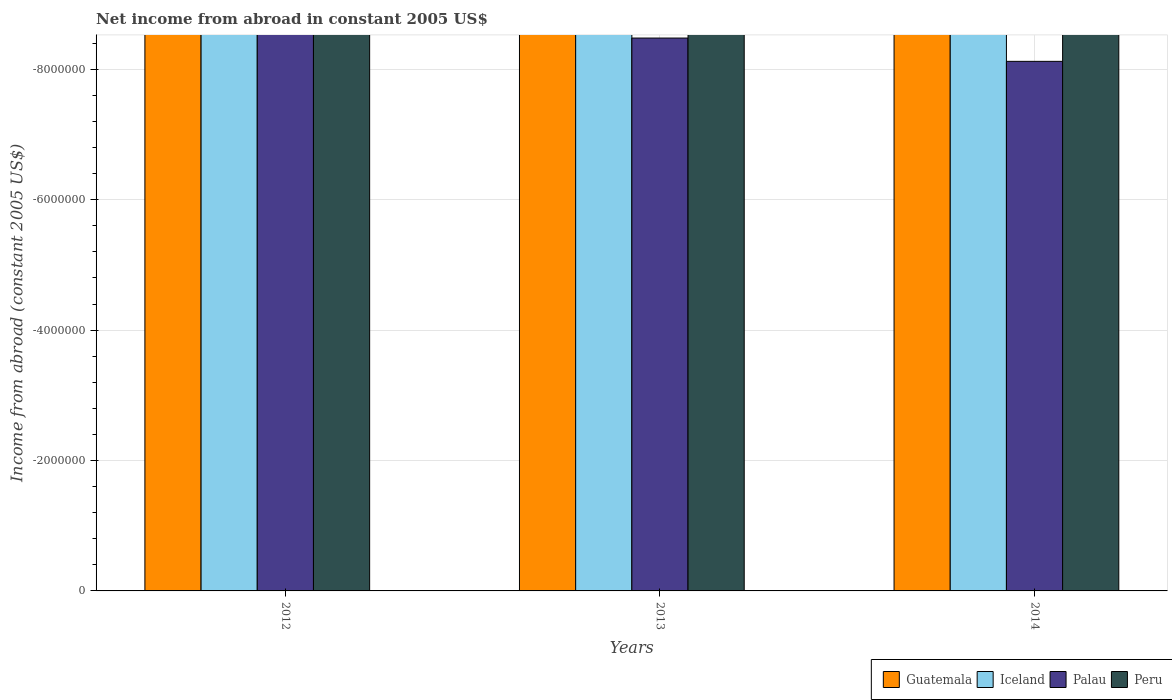How many bars are there on the 3rd tick from the left?
Offer a terse response. 0. In how many cases, is the number of bars for a given year not equal to the number of legend labels?
Provide a succinct answer. 3. Across all years, what is the minimum net income from abroad in Peru?
Offer a very short reply. 0. What is the total net income from abroad in Iceland in the graph?
Make the answer very short. 0. Is it the case that in every year, the sum of the net income from abroad in Peru and net income from abroad in Guatemala is greater than the sum of net income from abroad in Iceland and net income from abroad in Palau?
Give a very brief answer. No. Is it the case that in every year, the sum of the net income from abroad in Iceland and net income from abroad in Peru is greater than the net income from abroad in Guatemala?
Provide a short and direct response. No. How many bars are there?
Keep it short and to the point. 0. Are all the bars in the graph horizontal?
Offer a very short reply. No. How many years are there in the graph?
Keep it short and to the point. 3. What is the difference between two consecutive major ticks on the Y-axis?
Offer a terse response. 2.00e+06. Are the values on the major ticks of Y-axis written in scientific E-notation?
Your answer should be compact. No. Does the graph contain any zero values?
Offer a very short reply. Yes. Does the graph contain grids?
Keep it short and to the point. Yes. Where does the legend appear in the graph?
Your answer should be compact. Bottom right. How many legend labels are there?
Offer a very short reply. 4. What is the title of the graph?
Offer a very short reply. Net income from abroad in constant 2005 US$. Does "Togo" appear as one of the legend labels in the graph?
Offer a very short reply. No. What is the label or title of the X-axis?
Your response must be concise. Years. What is the label or title of the Y-axis?
Provide a succinct answer. Income from abroad (constant 2005 US$). What is the Income from abroad (constant 2005 US$) of Iceland in 2012?
Your answer should be very brief. 0. What is the Income from abroad (constant 2005 US$) of Palau in 2012?
Give a very brief answer. 0. What is the Income from abroad (constant 2005 US$) of Peru in 2012?
Give a very brief answer. 0. What is the Income from abroad (constant 2005 US$) in Guatemala in 2013?
Ensure brevity in your answer.  0. What is the Income from abroad (constant 2005 US$) of Iceland in 2013?
Ensure brevity in your answer.  0. What is the Income from abroad (constant 2005 US$) in Palau in 2013?
Keep it short and to the point. 0. What is the Income from abroad (constant 2005 US$) in Peru in 2013?
Your answer should be very brief. 0. What is the Income from abroad (constant 2005 US$) in Guatemala in 2014?
Your response must be concise. 0. What is the Income from abroad (constant 2005 US$) in Iceland in 2014?
Give a very brief answer. 0. What is the Income from abroad (constant 2005 US$) of Palau in 2014?
Your answer should be very brief. 0. What is the total Income from abroad (constant 2005 US$) of Peru in the graph?
Offer a terse response. 0. What is the average Income from abroad (constant 2005 US$) of Peru per year?
Provide a succinct answer. 0. 